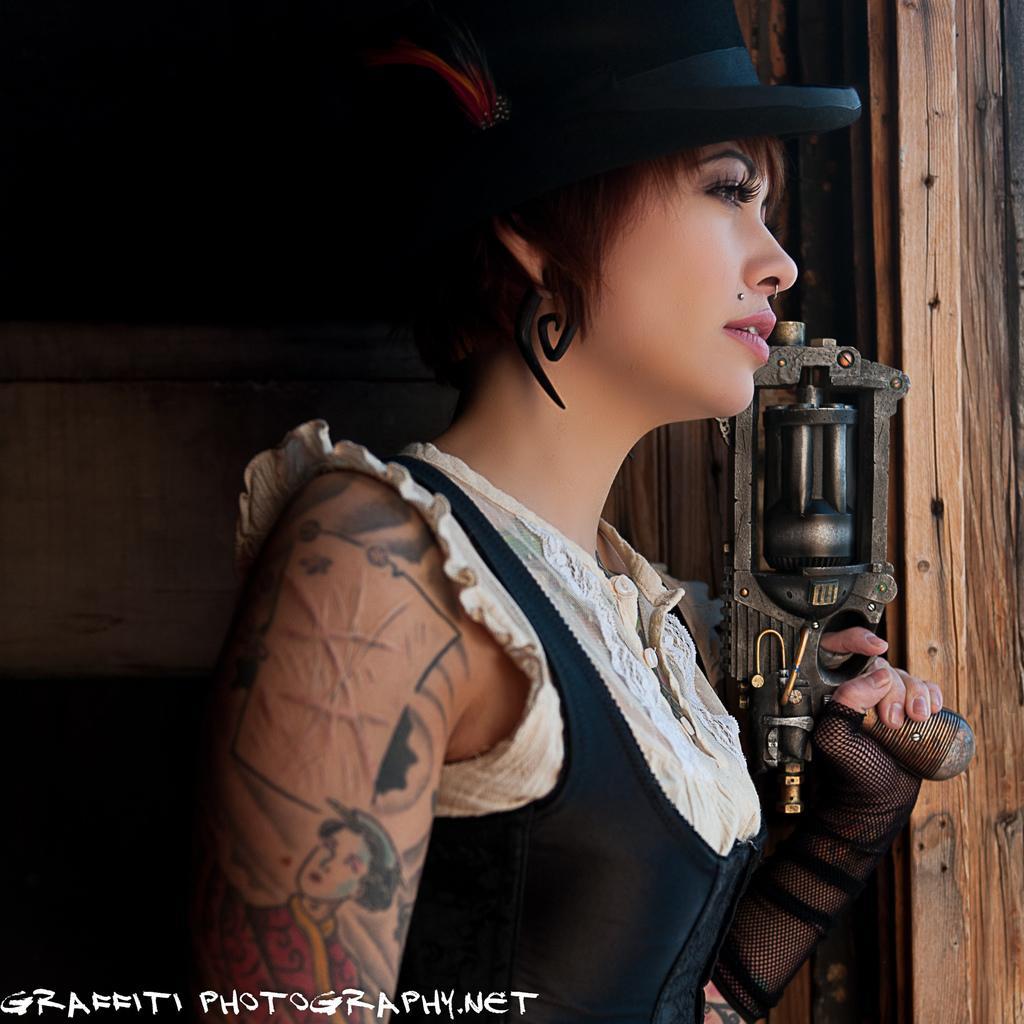Can you describe this image briefly? In the picture I can see a woman is standing. The woman is wearing a black color hat, clothes and some other objects. In the background I can see metal objects and on the bottom left corner of the image I can see a watermark. 